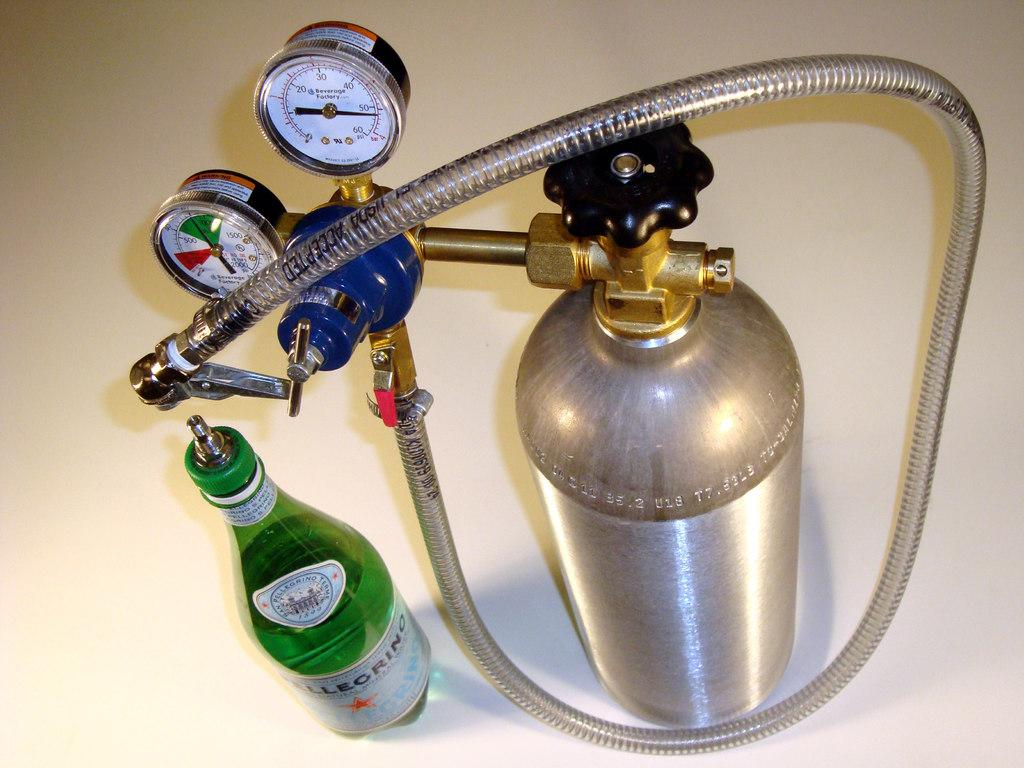What is the main object in the image? There is a cylinder with a pipe in the image. What is associated with the cylinder? There are meters associated with the cylinder. What type of bottle can be seen in the image? There is a green-colored bottle in the image. Where is the playground located in the image? There is no playground present in the image. What type of silk is used to make the bottle in the image? The image does not show a bottle made of silk, nor does it show any silk at all. 